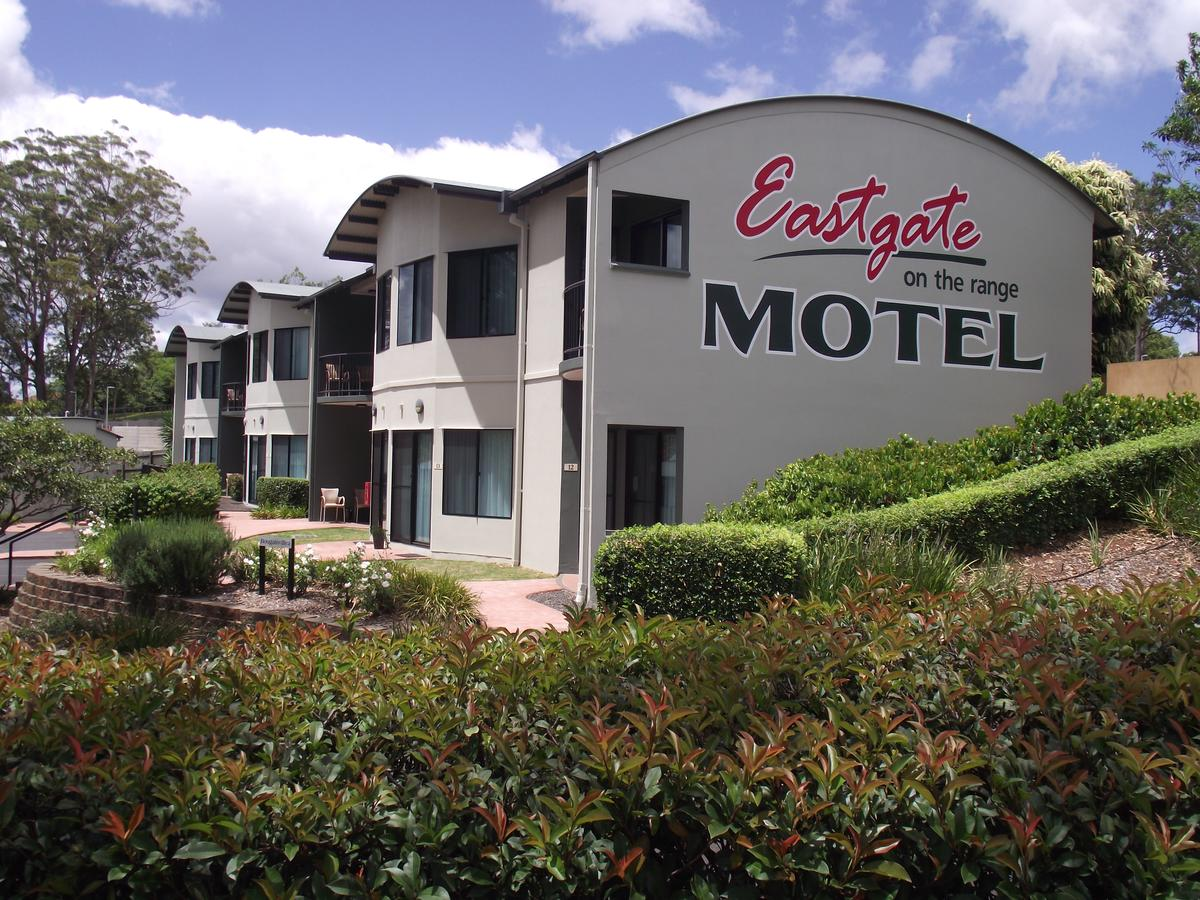Can you describe any subtle architectural details of the motel that might be easy to overlook? The motel features subtly curved edges around the roofing, and some balconies have geometric metal railings that add a modern touch to the otherwise straightforward design. Small lanterns on the walls beside each door provide both aesthetic and functional value by enhancing the overall ambiance and offering needed illumination. 